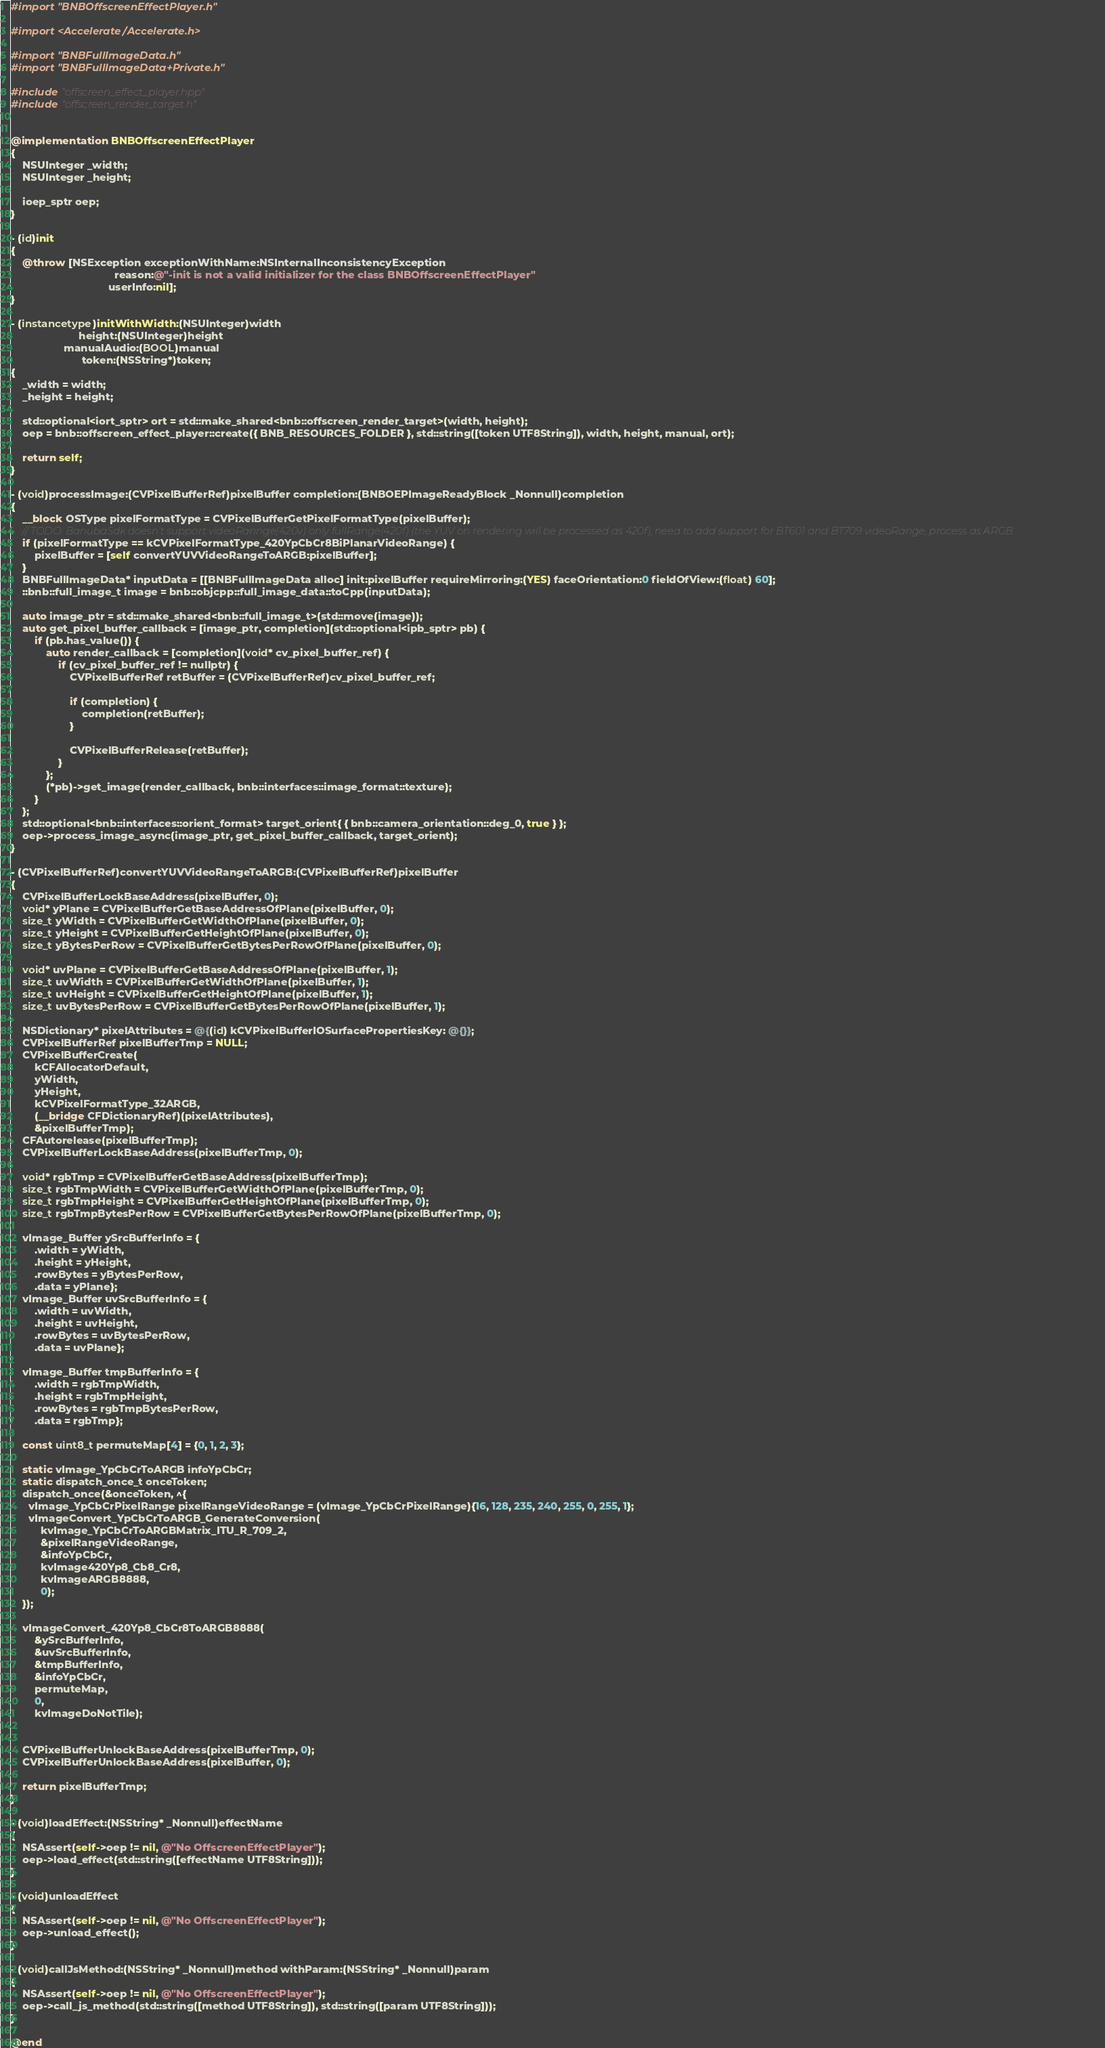<code> <loc_0><loc_0><loc_500><loc_500><_ObjectiveC_>#import "BNBOffscreenEffectPlayer.h"

#import <Accelerate/Accelerate.h>

#import "BNBFullImageData.h"
#import "BNBFullImageData+Private.h"

#include "offscreen_effect_player.hpp"
#include "offscreen_render_target.h"


@implementation BNBOffscreenEffectPlayer
{
    NSUInteger _width;
    NSUInteger _height;

    ioep_sptr oep;
}

- (id)init
{
    @throw [NSException exceptionWithName:NSInternalInconsistencyException
                                   reason:@"-init is not a valid initializer for the class BNBOffscreenEffectPlayer"
                                 userInfo:nil];
}

- (instancetype)initWithWidth:(NSUInteger)width
                       height:(NSUInteger)height
                  manualAudio:(BOOL)manual
                        token:(NSString*)token;
{
    _width = width;
    _height = height;

    std::optional<iort_sptr> ort = std::make_shared<bnb::offscreen_render_target>(width, height);
    oep = bnb::offscreen_effect_player::create({ BNB_RESOURCES_FOLDER }, std::string([token UTF8String]), width, height, manual, ort);

    return self;
}

- (void)processImage:(CVPixelBufferRef)pixelBuffer completion:(BNBOEPImageReadyBlock _Nonnull)completion
{
    __block OSType pixelFormatType = CVPixelBufferGetPixelFormatType(pixelBuffer);
    // TODO: BanubaSdk doesn't support videoRannge(420v) only fullRange(420f) (the YUV on rendering will be processed as 420f), need to add support for BT601 and BT709 videoRange, process as ARGB
    if (pixelFormatType == kCVPixelFormatType_420YpCbCr8BiPlanarVideoRange) {
        pixelBuffer = [self convertYUVVideoRangeToARGB:pixelBuffer];
    }
    BNBFullImageData* inputData = [[BNBFullImageData alloc] init:pixelBuffer requireMirroring:(YES) faceOrientation:0 fieldOfView:(float) 60];
    ::bnb::full_image_t image = bnb::objcpp::full_image_data::toCpp(inputData);

    auto image_ptr = std::make_shared<bnb::full_image_t>(std::move(image));
    auto get_pixel_buffer_callback = [image_ptr, completion](std::optional<ipb_sptr> pb) {
        if (pb.has_value()) {
            auto render_callback = [completion](void* cv_pixel_buffer_ref) {
                if (cv_pixel_buffer_ref != nullptr) {
                    CVPixelBufferRef retBuffer = (CVPixelBufferRef)cv_pixel_buffer_ref;

                    if (completion) {
                        completion(retBuffer);
                    }

                    CVPixelBufferRelease(retBuffer);
                }
            };
            (*pb)->get_image(render_callback, bnb::interfaces::image_format::texture);
        }
    };
    std::optional<bnb::interfaces::orient_format> target_orient{ { bnb::camera_orientation::deg_0, true } };
    oep->process_image_async(image_ptr, get_pixel_buffer_callback, target_orient);
}

- (CVPixelBufferRef)convertYUVVideoRangeToARGB:(CVPixelBufferRef)pixelBuffer
{
    CVPixelBufferLockBaseAddress(pixelBuffer, 0);
    void* yPlane = CVPixelBufferGetBaseAddressOfPlane(pixelBuffer, 0);
    size_t yWidth = CVPixelBufferGetWidthOfPlane(pixelBuffer, 0);
    size_t yHeight = CVPixelBufferGetHeightOfPlane(pixelBuffer, 0);
    size_t yBytesPerRow = CVPixelBufferGetBytesPerRowOfPlane(pixelBuffer, 0);

    void* uvPlane = CVPixelBufferGetBaseAddressOfPlane(pixelBuffer, 1);
    size_t uvWidth = CVPixelBufferGetWidthOfPlane(pixelBuffer, 1);
    size_t uvHeight = CVPixelBufferGetHeightOfPlane(pixelBuffer, 1);
    size_t uvBytesPerRow = CVPixelBufferGetBytesPerRowOfPlane(pixelBuffer, 1);

    NSDictionary* pixelAttributes = @{(id) kCVPixelBufferIOSurfacePropertiesKey: @{}};
    CVPixelBufferRef pixelBufferTmp = NULL;
    CVPixelBufferCreate(
        kCFAllocatorDefault,
        yWidth,
        yHeight,
        kCVPixelFormatType_32ARGB,
        (__bridge CFDictionaryRef)(pixelAttributes),
        &pixelBufferTmp);
    CFAutorelease(pixelBufferTmp);
    CVPixelBufferLockBaseAddress(pixelBufferTmp, 0);

    void* rgbTmp = CVPixelBufferGetBaseAddress(pixelBufferTmp);
    size_t rgbTmpWidth = CVPixelBufferGetWidthOfPlane(pixelBufferTmp, 0);
    size_t rgbTmpHeight = CVPixelBufferGetHeightOfPlane(pixelBufferTmp, 0);
    size_t rgbTmpBytesPerRow = CVPixelBufferGetBytesPerRowOfPlane(pixelBufferTmp, 0);

    vImage_Buffer ySrcBufferInfo = {
        .width = yWidth,
        .height = yHeight,
        .rowBytes = yBytesPerRow,
        .data = yPlane};
    vImage_Buffer uvSrcBufferInfo = {
        .width = uvWidth,
        .height = uvHeight,
        .rowBytes = uvBytesPerRow,
        .data = uvPlane};

    vImage_Buffer tmpBufferInfo = {
        .width = rgbTmpWidth,
        .height = rgbTmpHeight,
        .rowBytes = rgbTmpBytesPerRow,
        .data = rgbTmp};

    const uint8_t permuteMap[4] = {0, 1, 2, 3};

    static vImage_YpCbCrToARGB infoYpCbCr;
    static dispatch_once_t onceToken;
    dispatch_once(&onceToken, ^{
      vImage_YpCbCrPixelRange pixelRangeVideoRange = (vImage_YpCbCrPixelRange){16, 128, 235, 240, 255, 0, 255, 1};
      vImageConvert_YpCbCrToARGB_GenerateConversion(
          kvImage_YpCbCrToARGBMatrix_ITU_R_709_2,
          &pixelRangeVideoRange,
          &infoYpCbCr,
          kvImage420Yp8_Cb8_Cr8,
          kvImageARGB8888,
          0);
    });

    vImageConvert_420Yp8_CbCr8ToARGB8888(
        &ySrcBufferInfo,
        &uvSrcBufferInfo,
        &tmpBufferInfo,
        &infoYpCbCr,
        permuteMap,
        0,
        kvImageDoNotTile);


    CVPixelBufferUnlockBaseAddress(pixelBufferTmp, 0);
    CVPixelBufferUnlockBaseAddress(pixelBuffer, 0);

    return pixelBufferTmp;
}

- (void)loadEffect:(NSString* _Nonnull)effectName
{
    NSAssert(self->oep != nil, @"No OffscreenEffectPlayer");
    oep->load_effect(std::string([effectName UTF8String]));
}

- (void)unloadEffect
{
    NSAssert(self->oep != nil, @"No OffscreenEffectPlayer");
    oep->unload_effect();
}

- (void)callJsMethod:(NSString* _Nonnull)method withParam:(NSString* _Nonnull)param
{
    NSAssert(self->oep != nil, @"No OffscreenEffectPlayer");
    oep->call_js_method(std::string([method UTF8String]), std::string([param UTF8String]));
}

@end
</code> 